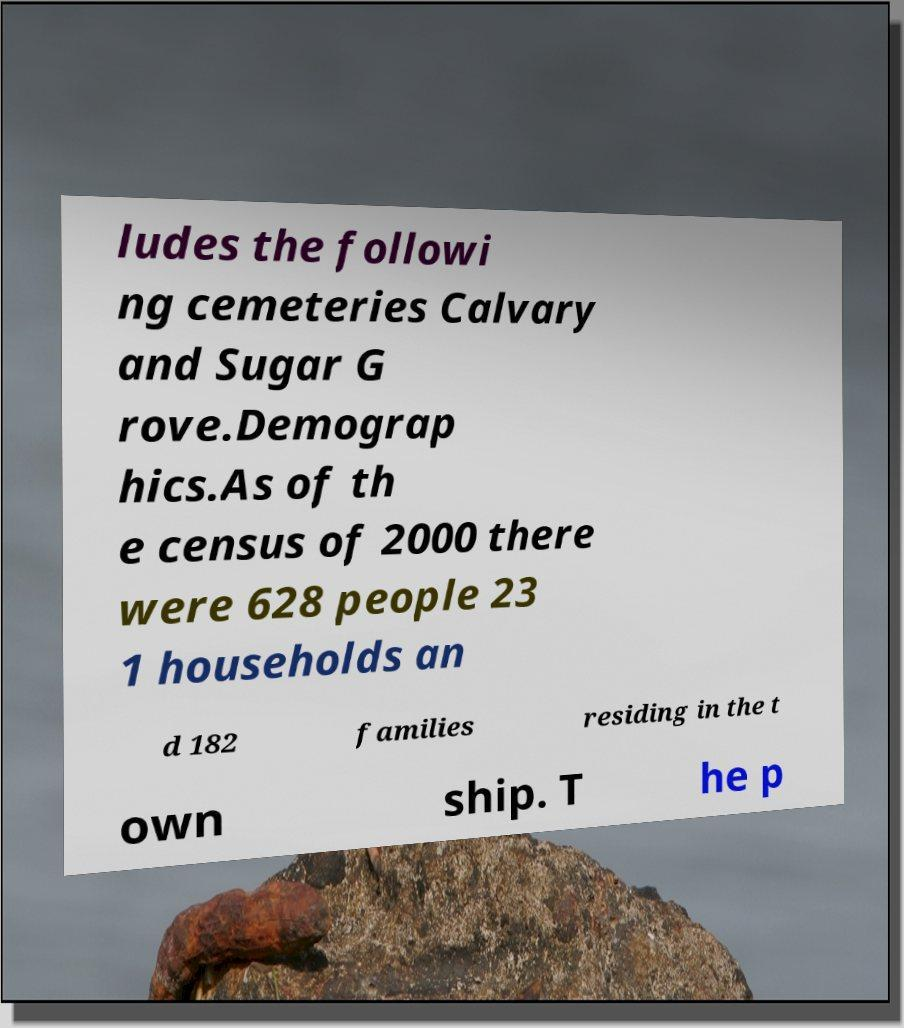Could you assist in decoding the text presented in this image and type it out clearly? ludes the followi ng cemeteries Calvary and Sugar G rove.Demograp hics.As of th e census of 2000 there were 628 people 23 1 households an d 182 families residing in the t own ship. T he p 